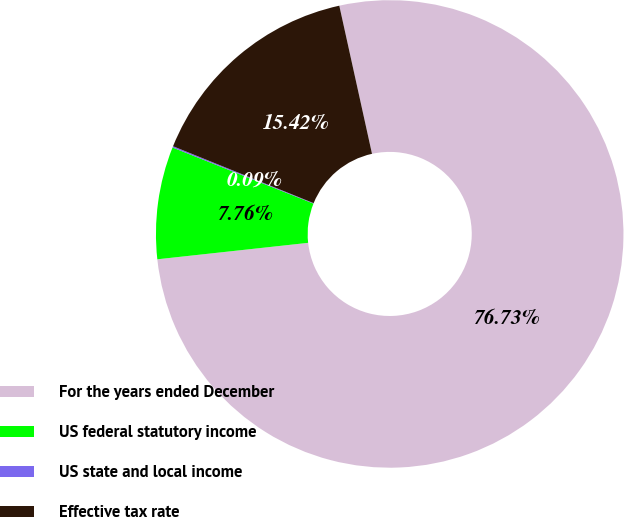<chart> <loc_0><loc_0><loc_500><loc_500><pie_chart><fcel>For the years ended December<fcel>US federal statutory income<fcel>US state and local income<fcel>Effective tax rate<nl><fcel>76.73%<fcel>7.76%<fcel>0.09%<fcel>15.42%<nl></chart> 